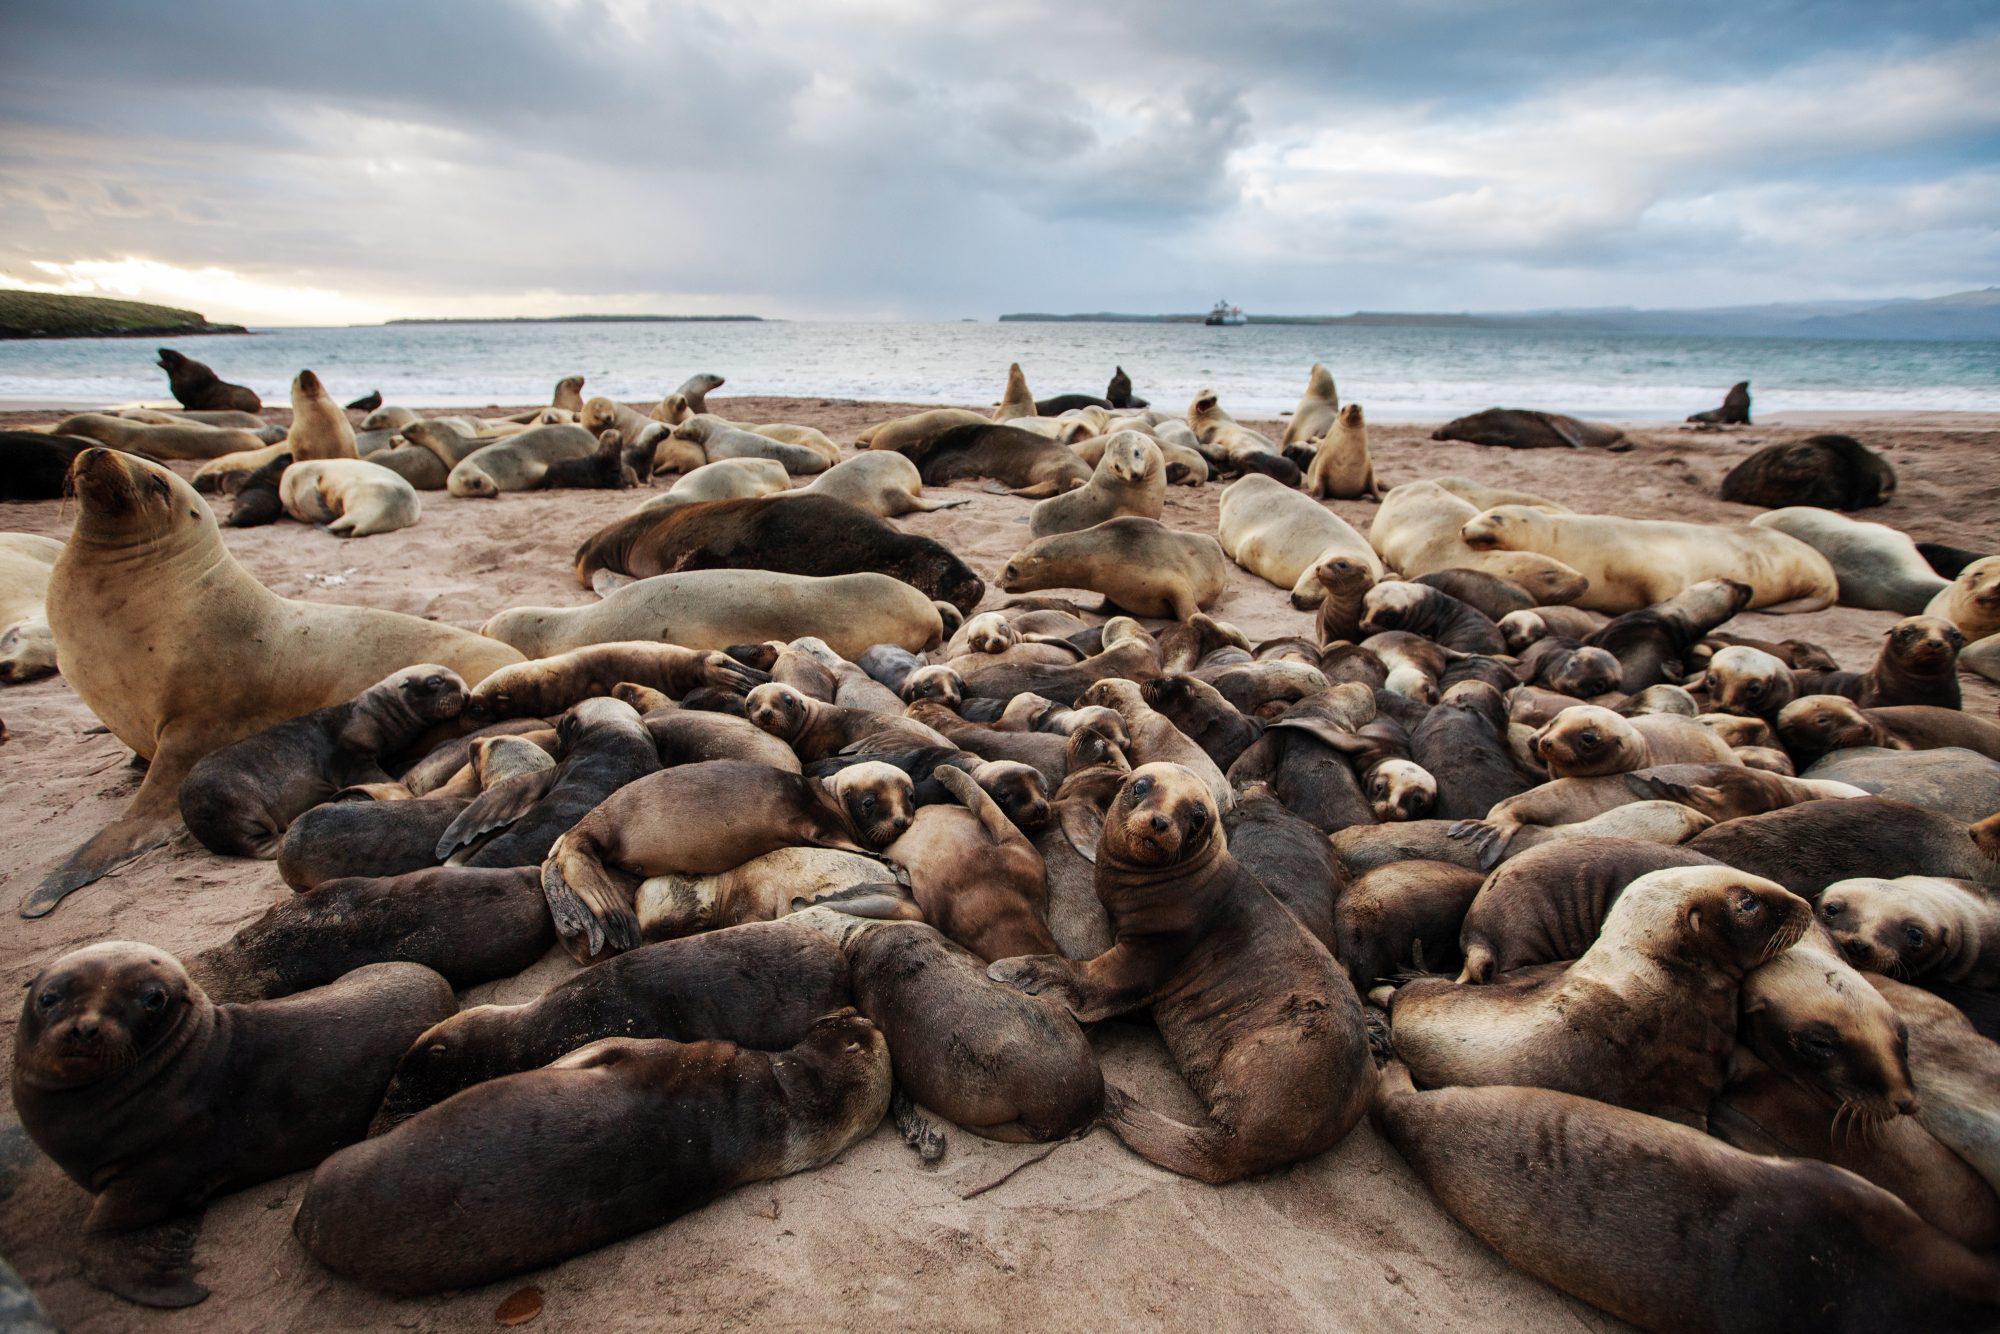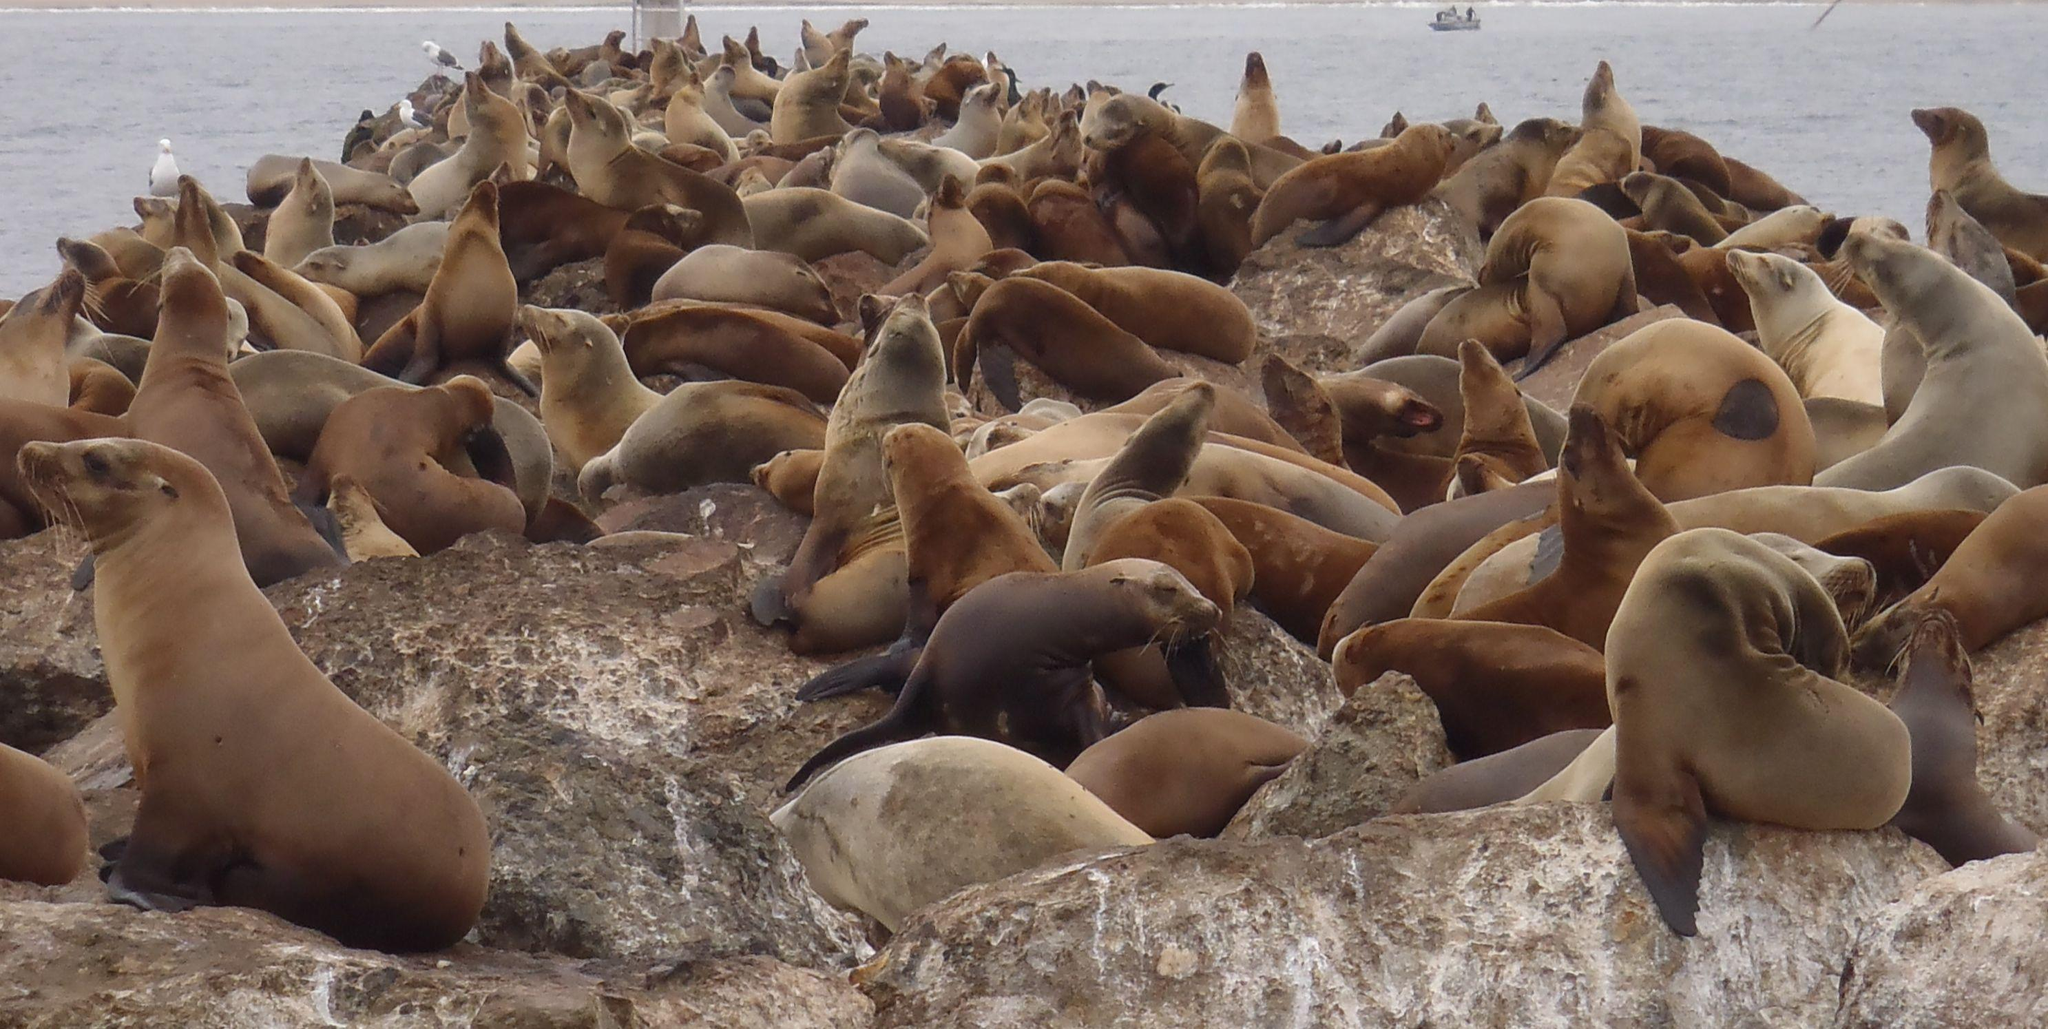The first image is the image on the left, the second image is the image on the right. Analyze the images presented: Is the assertion "In the foreground of an image, a left-facing small dark seal has its nose close to a bigger, paler seal." valid? Answer yes or no. No. 